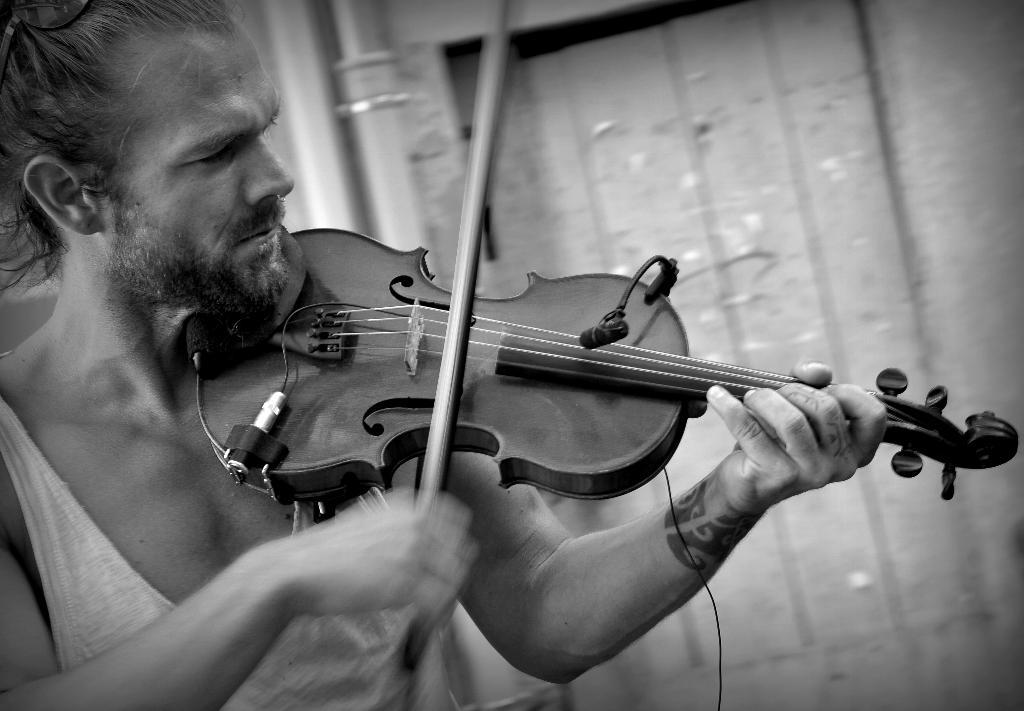What is there is a person in the image, what are they doing? The person in the image is playing a violin. Can you describe the person's activity in more detail? The person is holding a violin and appears to be making music by moving a bow across the strings. What type of rice is the scarecrow holding in the image? There is no scarecrow or rice present in the image; it features a person playing a violin. 